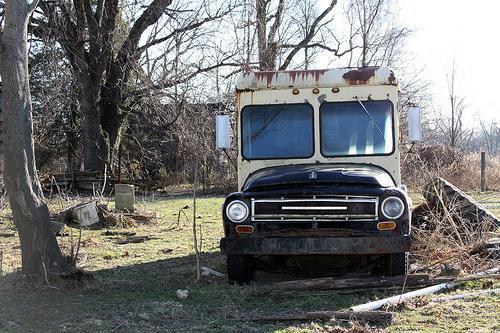How many windshields do you see?
Give a very brief answer. 2. How many side mirrors can you see?
Give a very brief answer. 2. How many fence poles do you see?
Give a very brief answer. 1. 